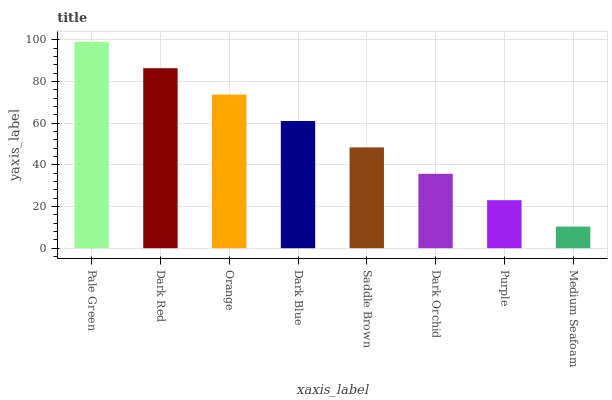Is Dark Red the minimum?
Answer yes or no. No. Is Dark Red the maximum?
Answer yes or no. No. Is Pale Green greater than Dark Red?
Answer yes or no. Yes. Is Dark Red less than Pale Green?
Answer yes or no. Yes. Is Dark Red greater than Pale Green?
Answer yes or no. No. Is Pale Green less than Dark Red?
Answer yes or no. No. Is Dark Blue the high median?
Answer yes or no. Yes. Is Saddle Brown the low median?
Answer yes or no. Yes. Is Purple the high median?
Answer yes or no. No. Is Dark Orchid the low median?
Answer yes or no. No. 